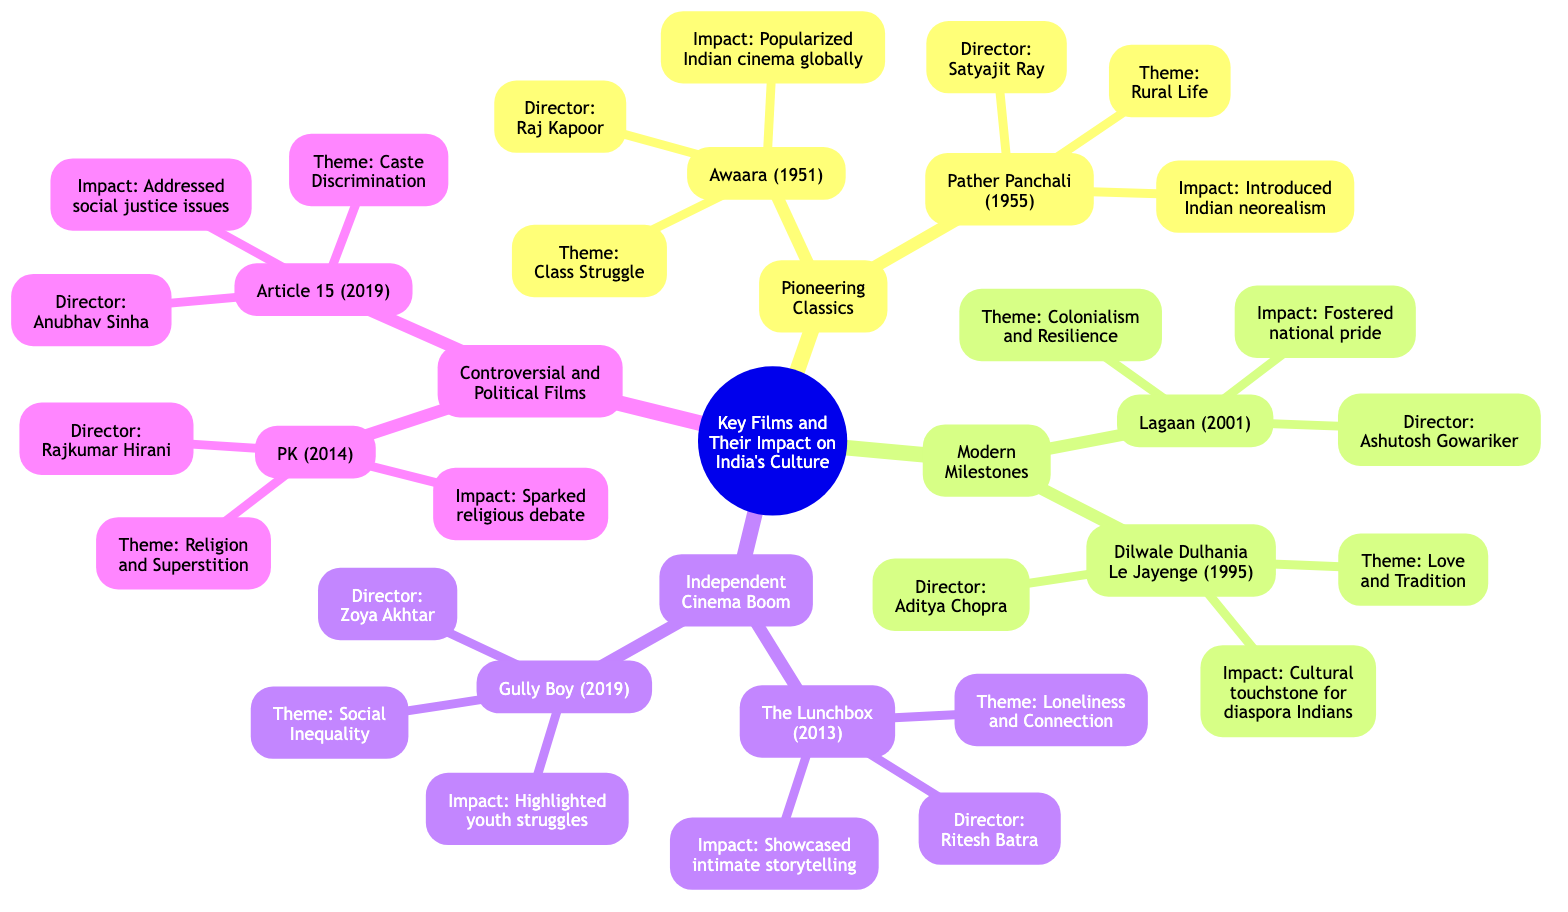What is the theme of "Awaara"? The diagram shows that "Awaara" has the theme "Class Struggle." This is directly indicated in the section about "Pioneering Classics."
Answer: Class Struggle Who directed "Pather Panchali"? The diagram specifies that "Pather Panchali" was directed by "Satyajit Ray," which is mentioned underneath the film title.
Answer: Satyajit Ray What cultural impact is associated with "Lagaan"? Under the "Modern Milestones" section, the impact specified for "Lagaan" is that it "Fostered national pride." This is the impact described in the diagram.
Answer: Fostered national pride How many films are listed under "Independent Cinema Boom"? The diagram lists two films, "The Lunchbox" and "Gully Boy," under that category. By counting these two entries, the answer emerges.
Answer: 2 Which film sparked debate on religious practices? From the "Controversial and Political Films" section, the diagram indicates that "PK" sparked widespread debate on religious practices. This is confirmed directly from the node descriptions.
Answer: PK Identify a film that addresses social justice issues. The "Article 15" film is specifically noted in the diagram for addressing social justice issues related to caste discrimination. This information is straightforward from the cultural impact description.
Answer: Article 15 What is the common theme of both "The Lunchbox" and "Gully Boy"? Both films share a theme of addressing personal challenges and societal conditions. The diagram notes that "The Lunchbox" deals with "Loneliness and Connection," while "Gully Boy" addresses "Social Inequality and Aspiration." Thus, both focus on the struggles of individuals or classes within society.
Answer: Struggles Which director is linked with the theme of Love and Tradition? The film "Dilwale Dulhania Le Jayenge," directed by "Aditya Chopra," is associated with the theme "Love and Tradition" in the diagram. The connection is made clear beneath the film's description.
Answer: Aditya Chopra What is the impact of "Gully Boy"? The impact stated in the diagram for "Gully Boy" is that it "Brought the underground rap scene into mainstream consciousness." This is explicitly mentioned in the cultural impact section of the film.
Answer: Brought the underground rap scene into mainstream consciousness 